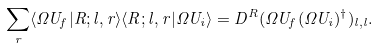<formula> <loc_0><loc_0><loc_500><loc_500>\sum _ { r } \langle \Omega U _ { f } | R ; l , r \rangle \langle R ; l , r | \Omega U _ { i } \rangle = D ^ { R } ( \Omega U _ { f } ( \Omega U _ { i } ) ^ { \dagger } ) _ { l , l } .</formula> 